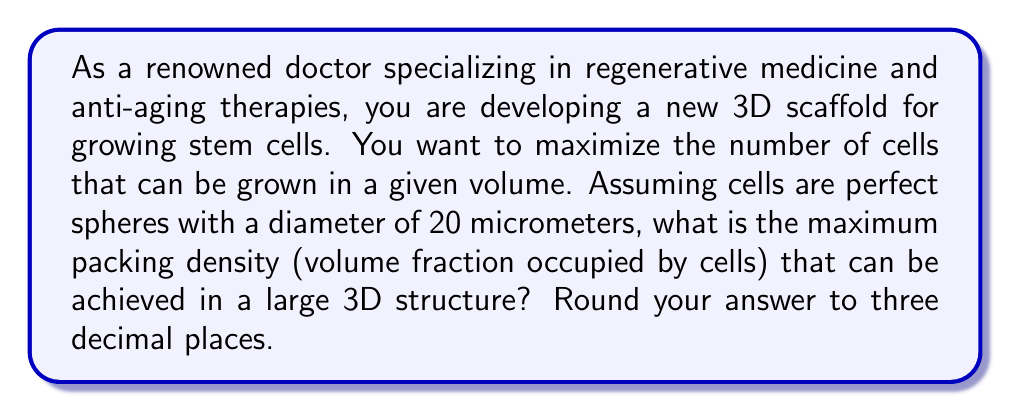Teach me how to tackle this problem. To solve this problem, we need to consider the optimal packing arrangement for spheres in 3D space. The most efficient packing arrangement for spheres is called close-packing, which can be achieved through either face-centered cubic (FCC) or hexagonal close-packed (HCP) structures.

1. In both FCC and HCP arrangements, each sphere is surrounded by 12 other spheres.

2. The packing density for both FCC and HCP is the same and can be calculated as follows:

   $$\text{Packing Density} = \frac{\text{Volume of spheres}}{\text{Total volume}}$$

3. In a unit cell of the close-packed structure, there are effectively 4 complete spheres.

4. The volume of a sphere is given by:
   $$V_{\text{sphere}} = \frac{4}{3}\pi r^3$$
   where $r$ is the radius of the sphere.

5. In the close-packed arrangement, the edge length of the cubic unit cell (a) is related to the sphere diameter (d) by:
   $$a = d\sqrt{2}$$

6. The volume of the cubic unit cell is:
   $$V_{\text{cell}} = a^3 = (d\sqrt{2})^3 = 2\sqrt{2}d^3$$

7. Therefore, the packing density is:
   $$\text{Packing Density} = \frac{4 \cdot \frac{4}{3}\pi (\frac{d}{2})^3}{2\sqrt{2}d^3} = \frac{4 \cdot \frac{4}{3}\pi (\frac{1}{2})^3}{2\sqrt{2}} = \frac{\pi}{3\sqrt{2}} \approx 0.74048$$

8. Rounding to three decimal places, we get 0.740 or 74.0%.

Note that this packing density is independent of the actual size of the spheres, so it applies to our 20-micrometer diameter cells.
Answer: 0.740 or 74.0% 